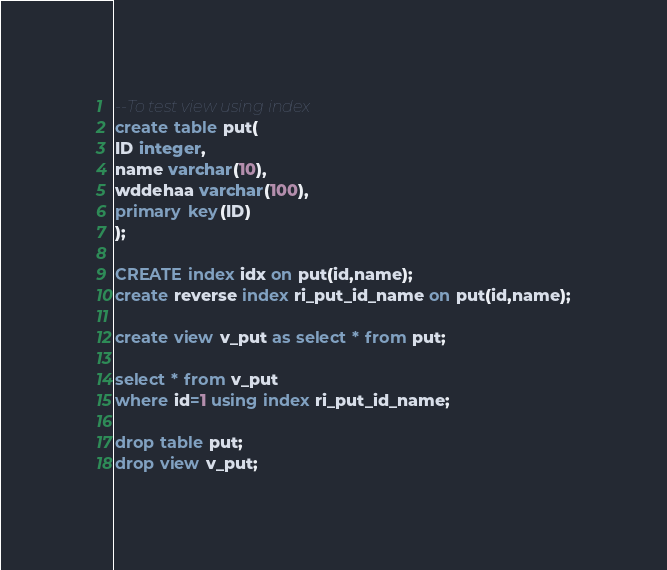Convert code to text. <code><loc_0><loc_0><loc_500><loc_500><_SQL_>--To test view using index
create table put(
ID integer,
name varchar(10),
wddehaa varchar(100),
primary key(ID)
);

CREATE index idx on put(id,name);
create reverse index ri_put_id_name on put(id,name);

create view v_put as select * from put;

select * from v_put
where id=1 using index ri_put_id_name;

drop table put;
drop view v_put;</code> 